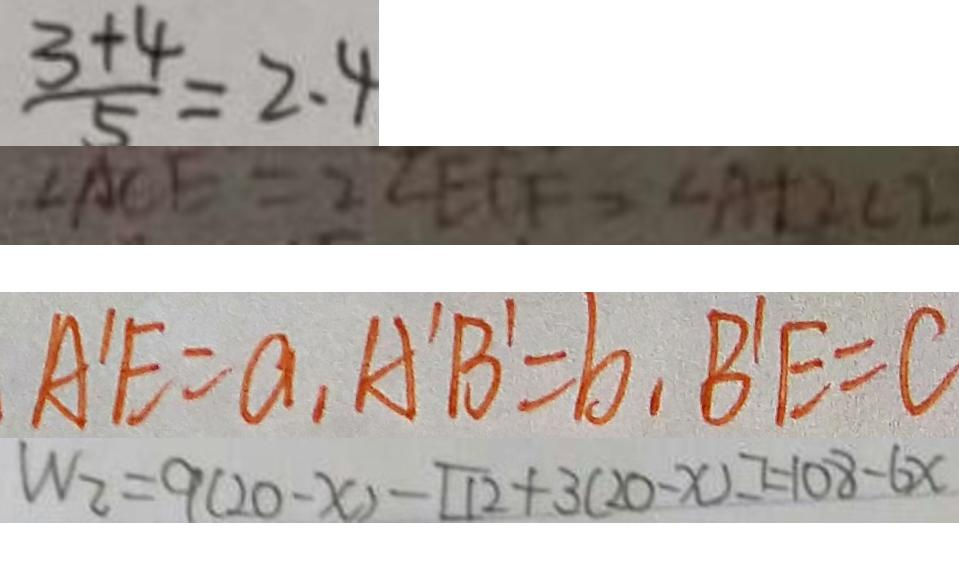Convert formula to latex. <formula><loc_0><loc_0><loc_500><loc_500>\frac { 3 + 4 } { 5 } = 2 . 4 
 \angle A C E = 2 \angle E C F - \angle A + 2 \angle E 
 A ^ { \prime } E = a , A ^ { \prime } B ^ { \prime } = b , B ^ { \prime } E = C 
 W _ { 2 } = 9 ( 2 0 - x ) - [ 1 2 + 3 ( 2 0 - x ) ] = 1 0 8 - 6 x</formula> 